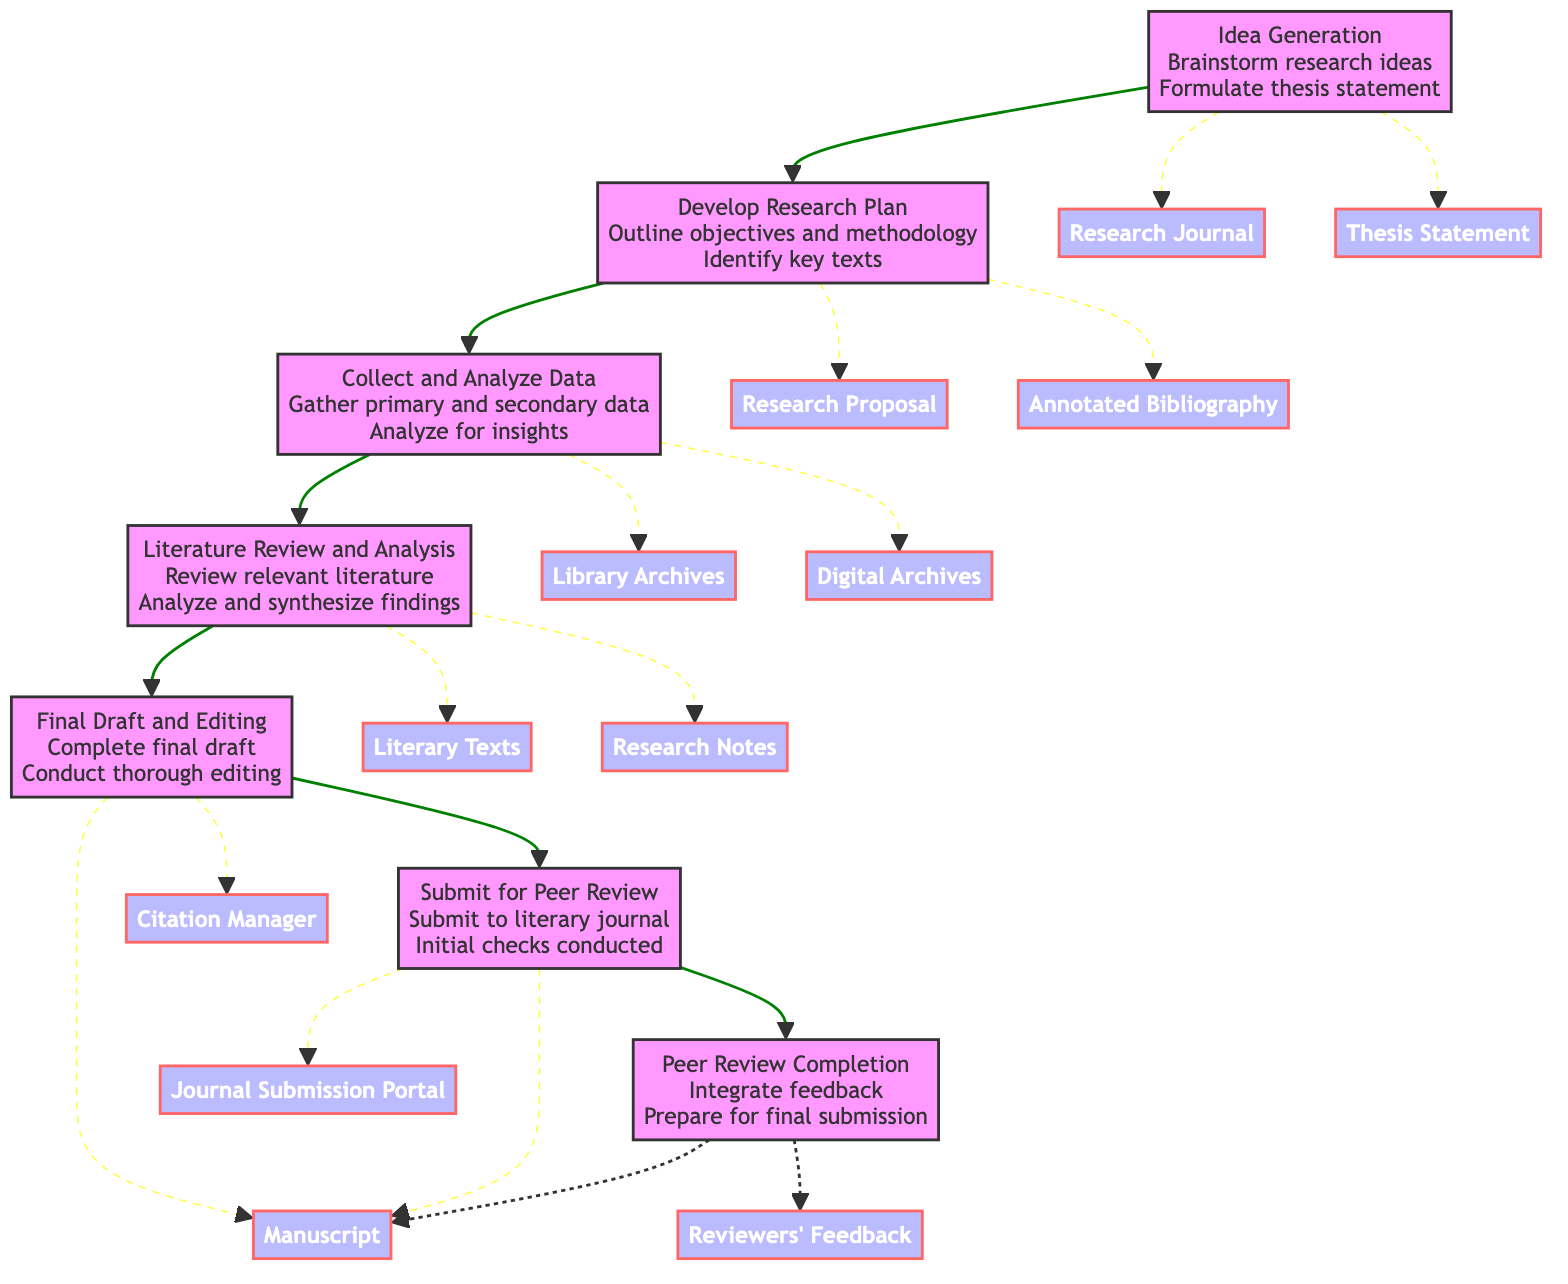What is the starting point of the workflow? The workflow begins at the "Idea Generation" node, which does not have a previous step and initiates the entire research process.
Answer: Idea Generation How many steps are there from "Literature Review and Analysis" to "Peer Review Completion"? The steps from "Literature Review and Analysis" to "Peer Review Completion" include Final Draft and Editing, Submit for Peer Review, totaling three steps.
Answer: 3 What is the final step of the workflow? The final step, concluding the entire research and publication process, is "Peer Review Completion."
Answer: Peer Review Completion Which step involves gathering data from libraries and archives? The step that specifically involves gathering primary and secondary data is called "Collect and Analyze Data."
Answer: Collect and Analyze Data What does the "Develop Research Plan" step outline? This step outlines the research objectives, methodology, and the identification of key texts and resources needed for the study.
Answer: Objectives, methodology, key texts What entities are mentioned in the "Final Draft and Editing" phase? The entities involved in this phase are "Manuscript" and "Citation Manager," which are necessary for completing the manuscript's final draft and ensuring citations are correct.
Answer: Manuscript, Citation Manager What is the relationship between "Collect and Analyze Data" and "Literature Review and Analysis"? The "Collect and Analyze Data" step feeds directly into "Literature Review and Analysis," implying that data collection is foundational for conducting a literature review.
Answer: Direct flow How many total entities are present in the workflow? Counting all the unique entities from each step, there are ten entities listed throughout the workflow.
Answer: 10 Which step includes reviewer feedback? The phase that includes integrating reviewer feedback in the manuscript is "Peer Review Completion."
Answer: Peer Review Completion 